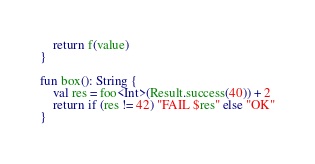Convert code to text. <code><loc_0><loc_0><loc_500><loc_500><_Kotlin_>    return f(value)
}

fun box(): String {
    val res = foo<Int>(Result.success(40)) + 2
    return if (res != 42) "FAIL $res" else "OK"
}</code> 